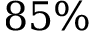<formula> <loc_0><loc_0><loc_500><loc_500>8 5 \%</formula> 